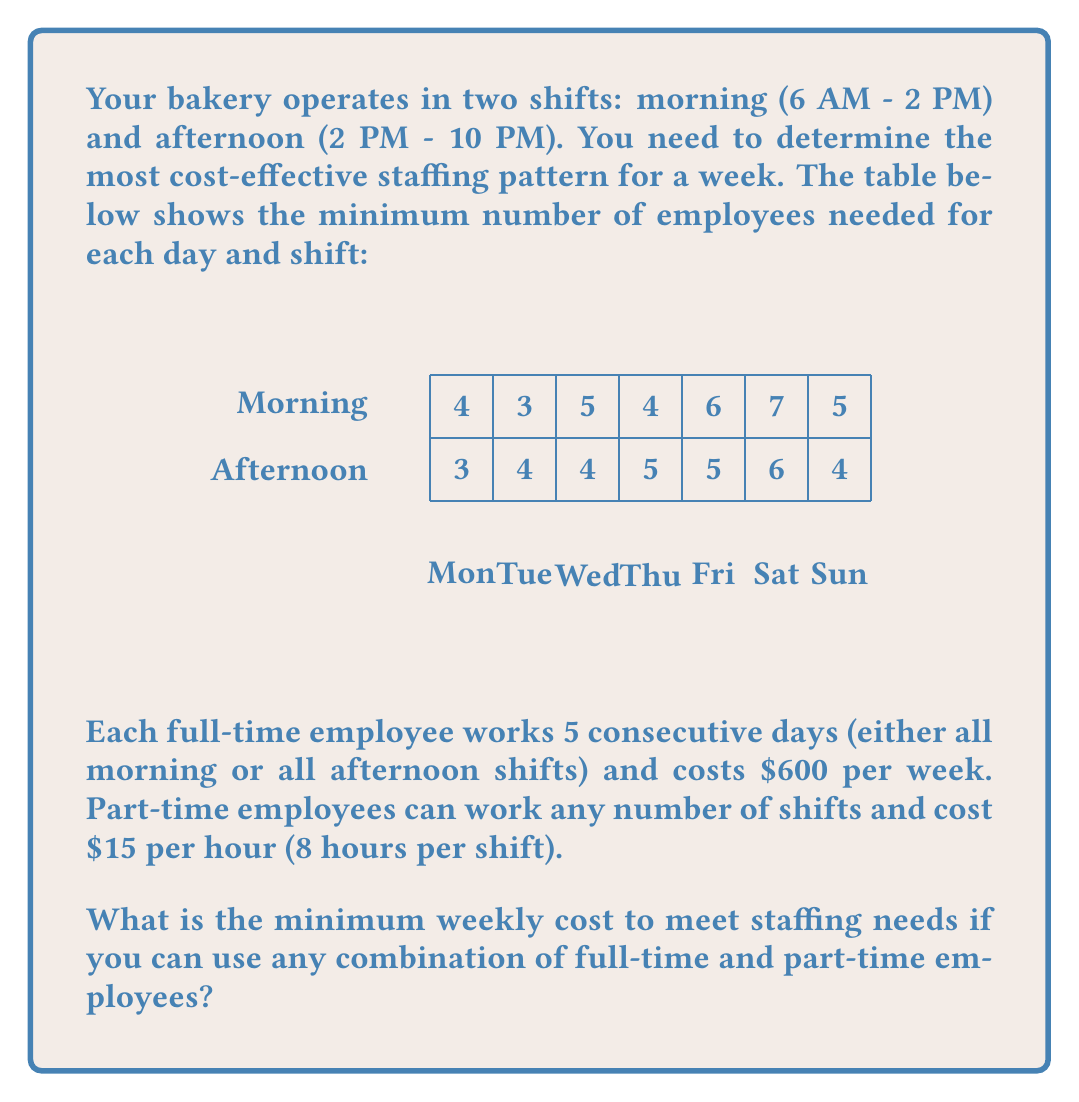Help me with this question. Let's approach this problem step-by-step:

1) First, we need to calculate the total number of shifts required for each type:
   Morning shifts: 4 + 3 + 5 + 4 + 6 + 7 + 5 = 34
   Afternoon shifts: 3 + 4 + 4 + 5 + 5 + 6 + 4 = 31

2) For full-time employees, we need to consider the most efficient way to schedule them:
   - Each full-time employee covers 5 shifts
   - We need to minimize the number of extra shifts covered

3) For morning shifts:
   - 6 full-time employees cover 30 shifts (6 * 5 = 30)
   - 4 shifts remain to be covered by part-time employees

4) For afternoon shifts:
   - 6 full-time employees cover 30 shifts
   - 1 shift remains to be covered by a part-time employee

5) Calculate the cost:
   - Full-time employees: 12 * $600 = $7,200
   - Part-time shifts: 5 * $15 * 8 = $600

6) Total cost: $7,200 + $600 = $7,800

We can verify that this is optimal:
- Using only part-time employees would cost: (34 + 31) * $15 * 8 = $7,800
- Any other combination of full-time and part-time would be more expensive

Therefore, the minimum weekly cost is $7,800.
Answer: $7,800 